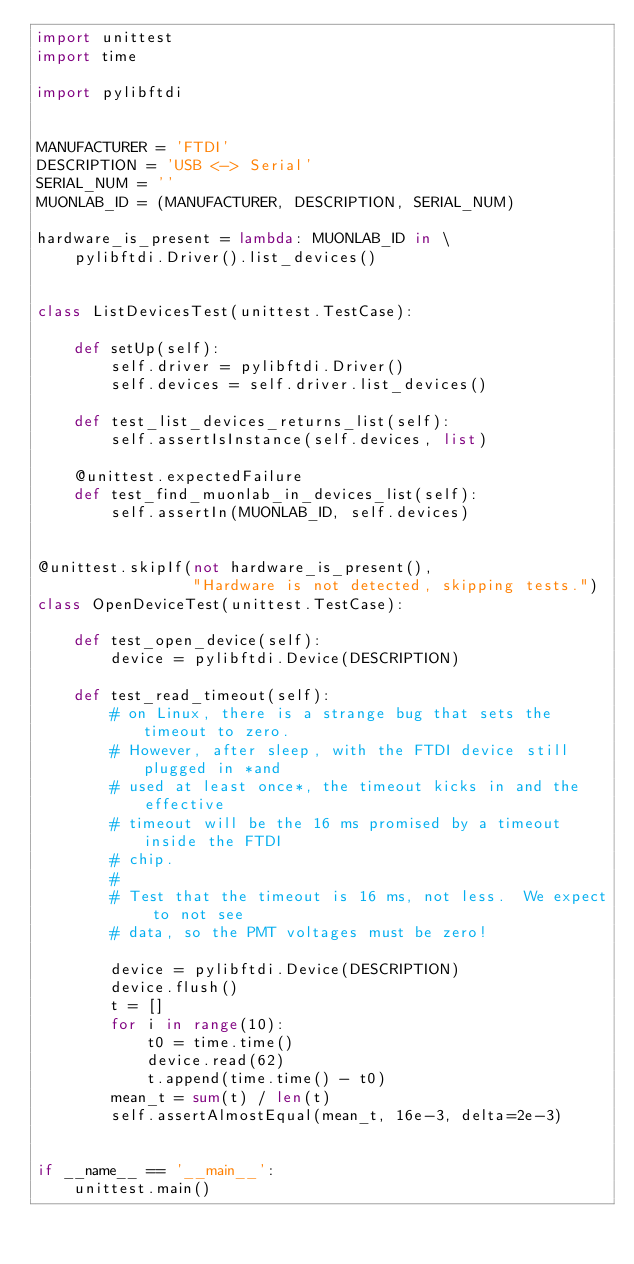<code> <loc_0><loc_0><loc_500><loc_500><_Python_>import unittest
import time

import pylibftdi


MANUFACTURER = 'FTDI'
DESCRIPTION = 'USB <-> Serial'
SERIAL_NUM = ''
MUONLAB_ID = (MANUFACTURER, DESCRIPTION, SERIAL_NUM)

hardware_is_present = lambda: MUONLAB_ID in \
    pylibftdi.Driver().list_devices()


class ListDevicesTest(unittest.TestCase):

    def setUp(self):
        self.driver = pylibftdi.Driver()
        self.devices = self.driver.list_devices()

    def test_list_devices_returns_list(self):
        self.assertIsInstance(self.devices, list)

    @unittest.expectedFailure
    def test_find_muonlab_in_devices_list(self):
        self.assertIn(MUONLAB_ID, self.devices)


@unittest.skipIf(not hardware_is_present(),
                 "Hardware is not detected, skipping tests.")
class OpenDeviceTest(unittest.TestCase):

    def test_open_device(self):
        device = pylibftdi.Device(DESCRIPTION)

    def test_read_timeout(self):
        # on Linux, there is a strange bug that sets the timeout to zero.
        # However, after sleep, with the FTDI device still plugged in *and
        # used at least once*, the timeout kicks in and the effective
        # timeout will be the 16 ms promised by a timeout inside the FTDI
        # chip.
        #
        # Test that the timeout is 16 ms, not less.  We expect to not see
        # data, so the PMT voltages must be zero!

        device = pylibftdi.Device(DESCRIPTION)
        device.flush()
        t = []
        for i in range(10):
            t0 = time.time()
            device.read(62)
            t.append(time.time() - t0)
        mean_t = sum(t) / len(t)
        self.assertAlmostEqual(mean_t, 16e-3, delta=2e-3)


if __name__ == '__main__':
    unittest.main()
</code> 